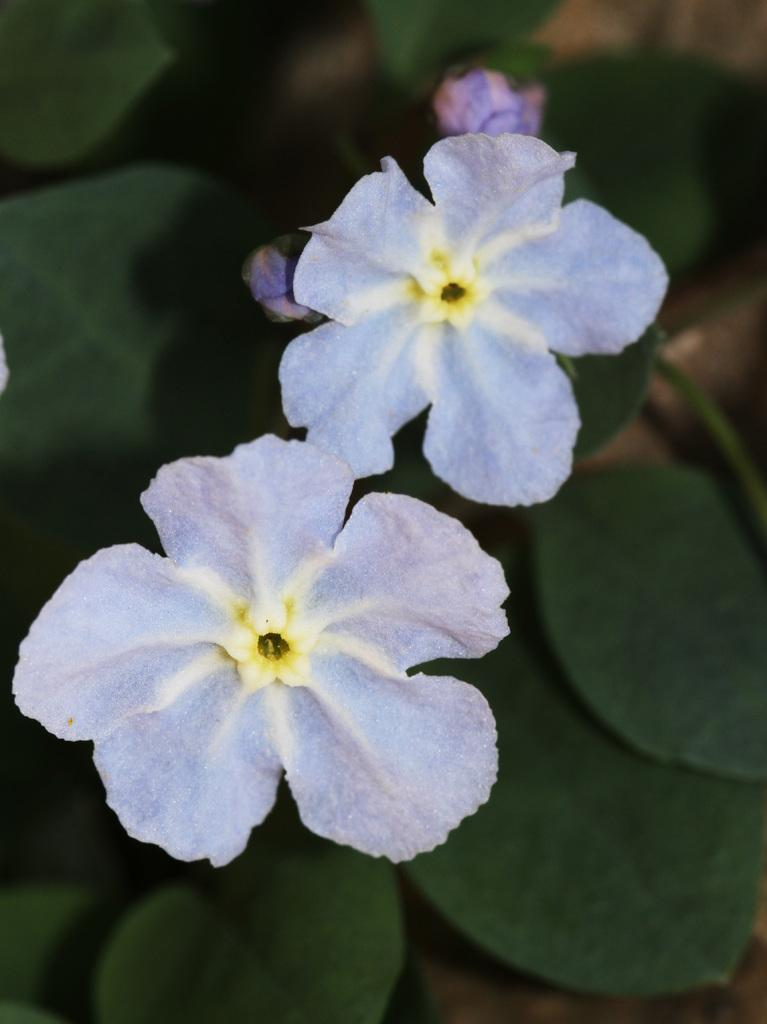What type of plant is visible in the image? There is a plant in the image, but the specific type cannot be determined from the facts provided. What features of the plant can be seen in the image? The plant has flowers, buds, and leaves. What type of laborer is working on the plant in the image? There is no laborer present in the image; it only features the plant. What direction is the sun shining on the plant in the image? The facts provided do not mention the sun or its position, so it cannot be determined from the image. 